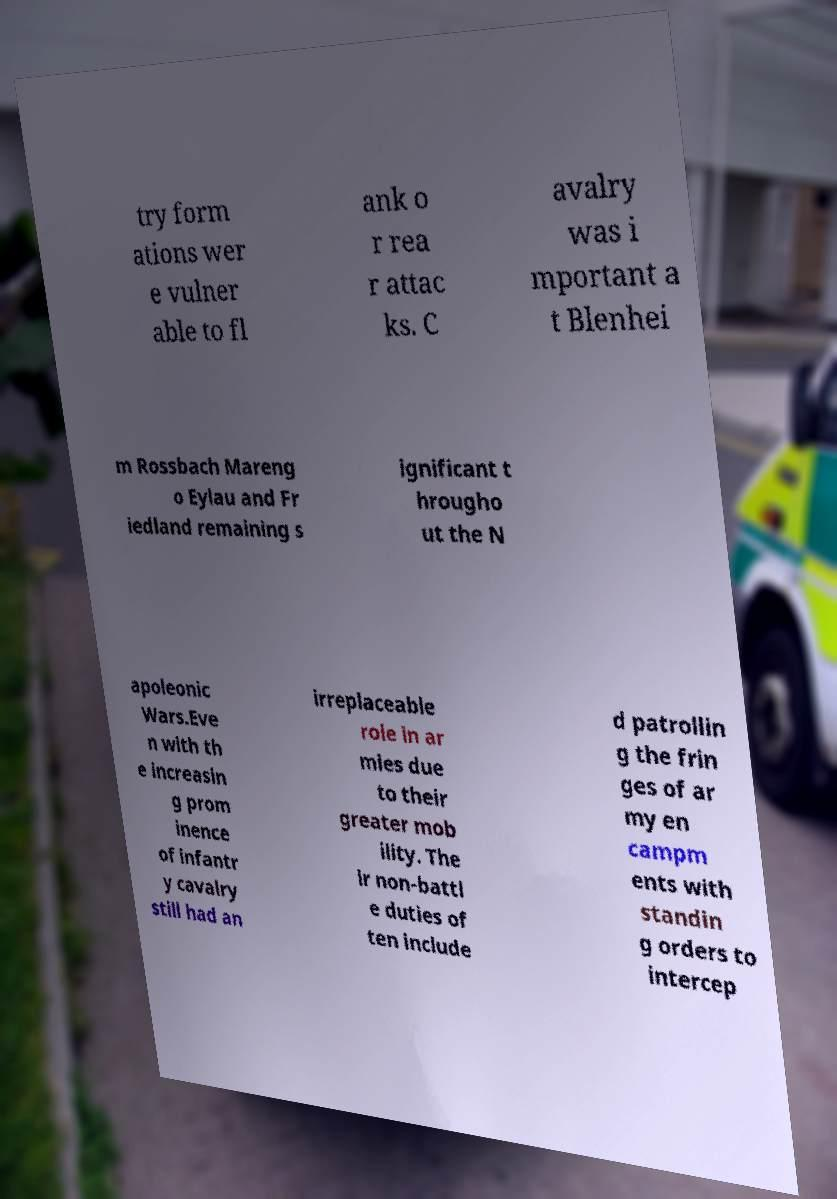For documentation purposes, I need the text within this image transcribed. Could you provide that? try form ations wer e vulner able to fl ank o r rea r attac ks. C avalry was i mportant a t Blenhei m Rossbach Mareng o Eylau and Fr iedland remaining s ignificant t hrougho ut the N apoleonic Wars.Eve n with th e increasin g prom inence of infantr y cavalry still had an irreplaceable role in ar mies due to their greater mob ility. The ir non-battl e duties of ten include d patrollin g the frin ges of ar my en campm ents with standin g orders to intercep 